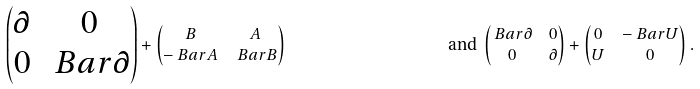<formula> <loc_0><loc_0><loc_500><loc_500>\begin{pmatrix} \partial & 0 \\ 0 & \ B a r { \partial } \end{pmatrix} & + \begin{pmatrix} B & A \\ - \ B a r { A } & \ B a r { B } \end{pmatrix} & \text {and } \begin{pmatrix} \ B a r { \partial } & 0 \\ 0 & \partial \end{pmatrix} & + \begin{pmatrix} 0 & - \ B a r { U } \\ U & 0 \end{pmatrix} .</formula> 